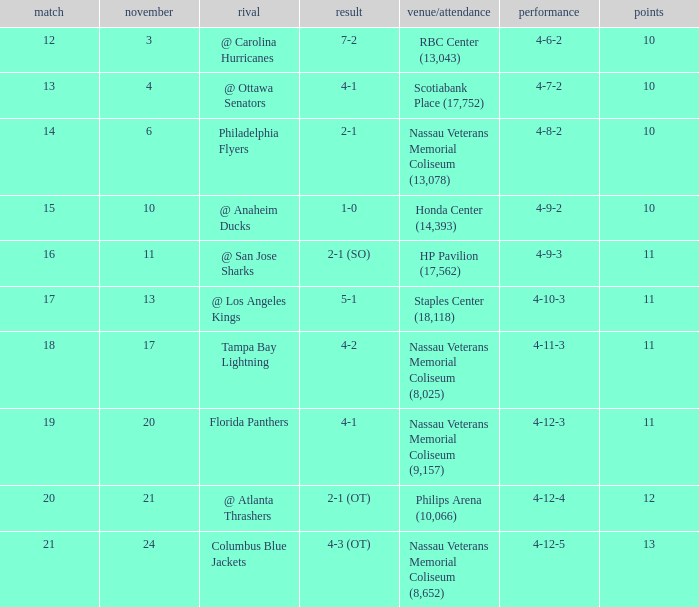What is the highest amount of points? 13.0. 